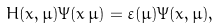<formula> <loc_0><loc_0><loc_500><loc_500>H ( x , \mu ) \Psi ( x \, \mu ) = \varepsilon ( \mu ) \Psi ( x , \mu ) ,</formula> 